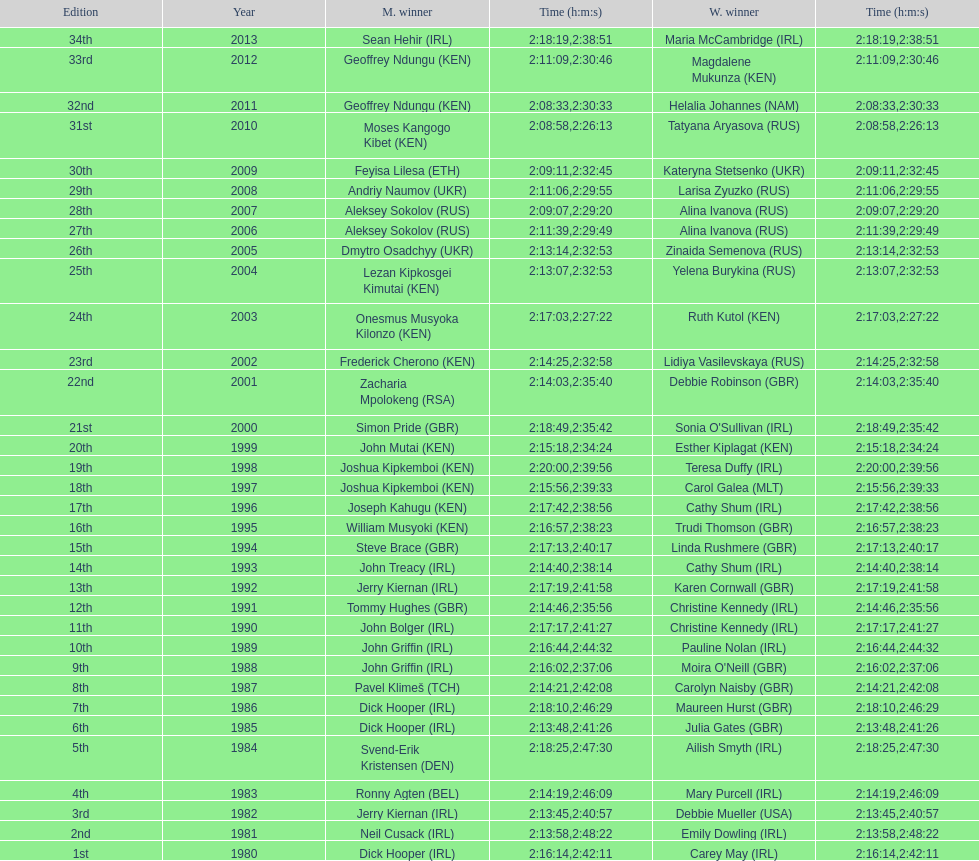Who had the maximum amount of time among all the runners? Maria McCambridge (IRL). 